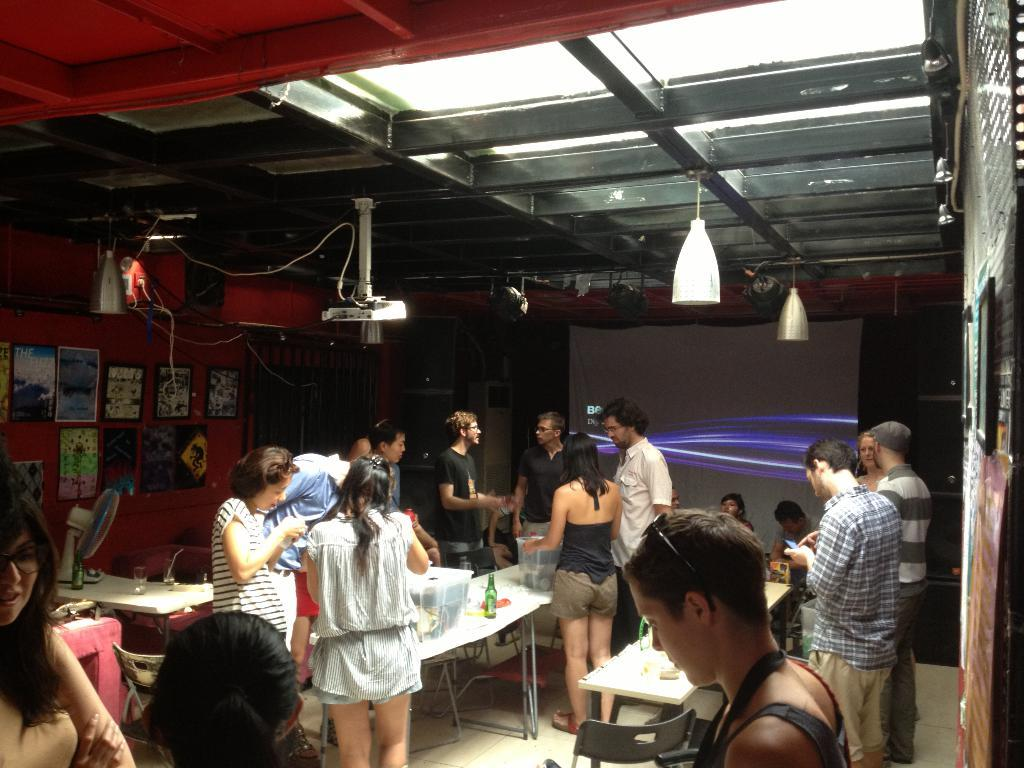What type of furniture can be seen in the image? There are tables in the image. What are the people in the image doing? There are people standing in the image. What is on the wall in the image? There are photos on the wall. What is the background of the image made of? The wall in the image is the background. Can you tell me how many people are embarking on a voyage in the image? There is no indication of a voyage or any travel-related activity in the image. What type of magic is being performed by the people in the image? There is no magic or any supernatural activity depicted in the image. 